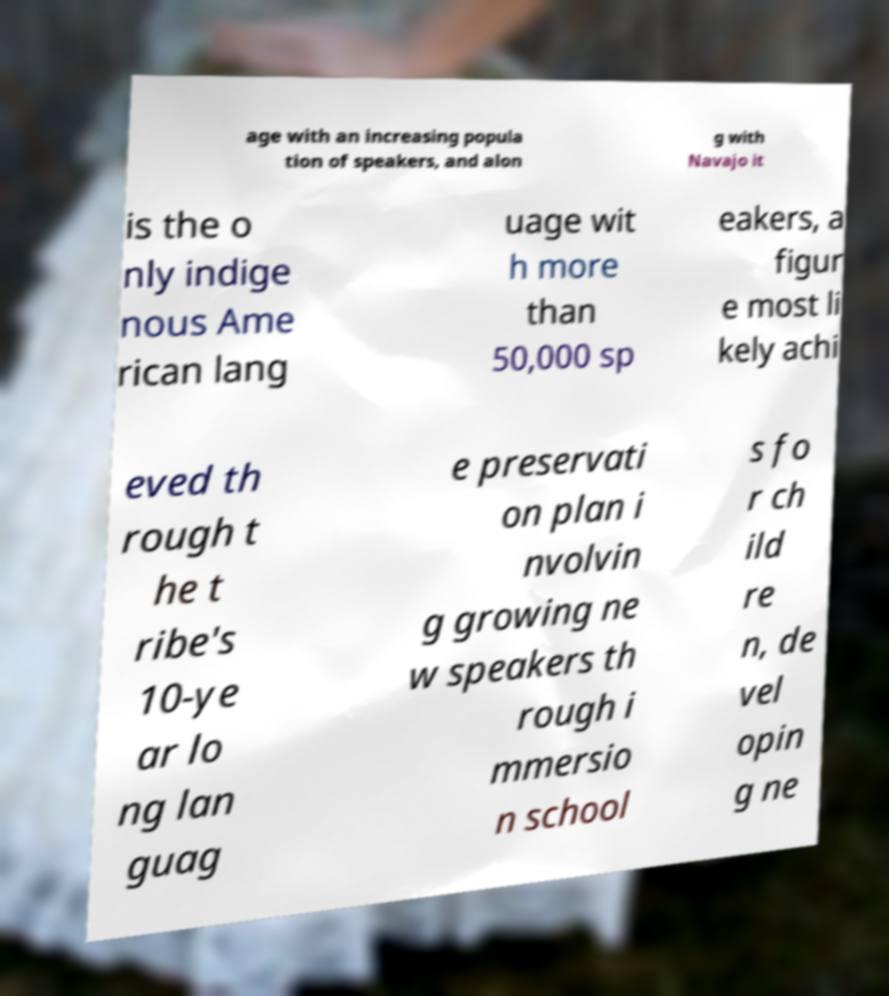What messages or text are displayed in this image? I need them in a readable, typed format. age with an increasing popula tion of speakers, and alon g with Navajo it is the o nly indige nous Ame rican lang uage wit h more than 50,000 sp eakers, a figur e most li kely achi eved th rough t he t ribe's 10-ye ar lo ng lan guag e preservati on plan i nvolvin g growing ne w speakers th rough i mmersio n school s fo r ch ild re n, de vel opin g ne 